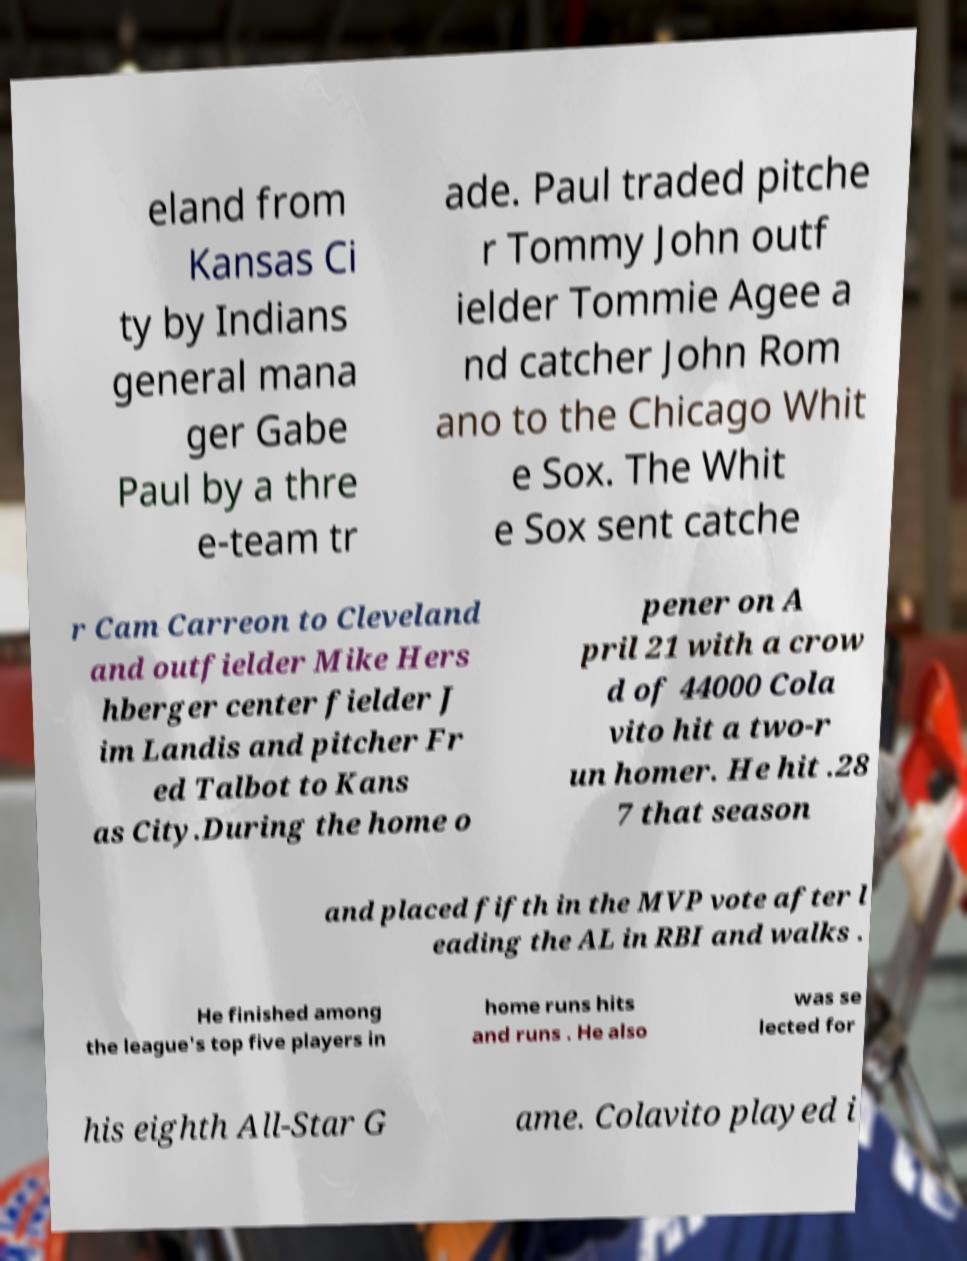Please read and relay the text visible in this image. What does it say? eland from Kansas Ci ty by Indians general mana ger Gabe Paul by a thre e-team tr ade. Paul traded pitche r Tommy John outf ielder Tommie Agee a nd catcher John Rom ano to the Chicago Whit e Sox. The Whit e Sox sent catche r Cam Carreon to Cleveland and outfielder Mike Hers hberger center fielder J im Landis and pitcher Fr ed Talbot to Kans as City.During the home o pener on A pril 21 with a crow d of 44000 Cola vito hit a two-r un homer. He hit .28 7 that season and placed fifth in the MVP vote after l eading the AL in RBI and walks . He finished among the league's top five players in home runs hits and runs . He also was se lected for his eighth All-Star G ame. Colavito played i 